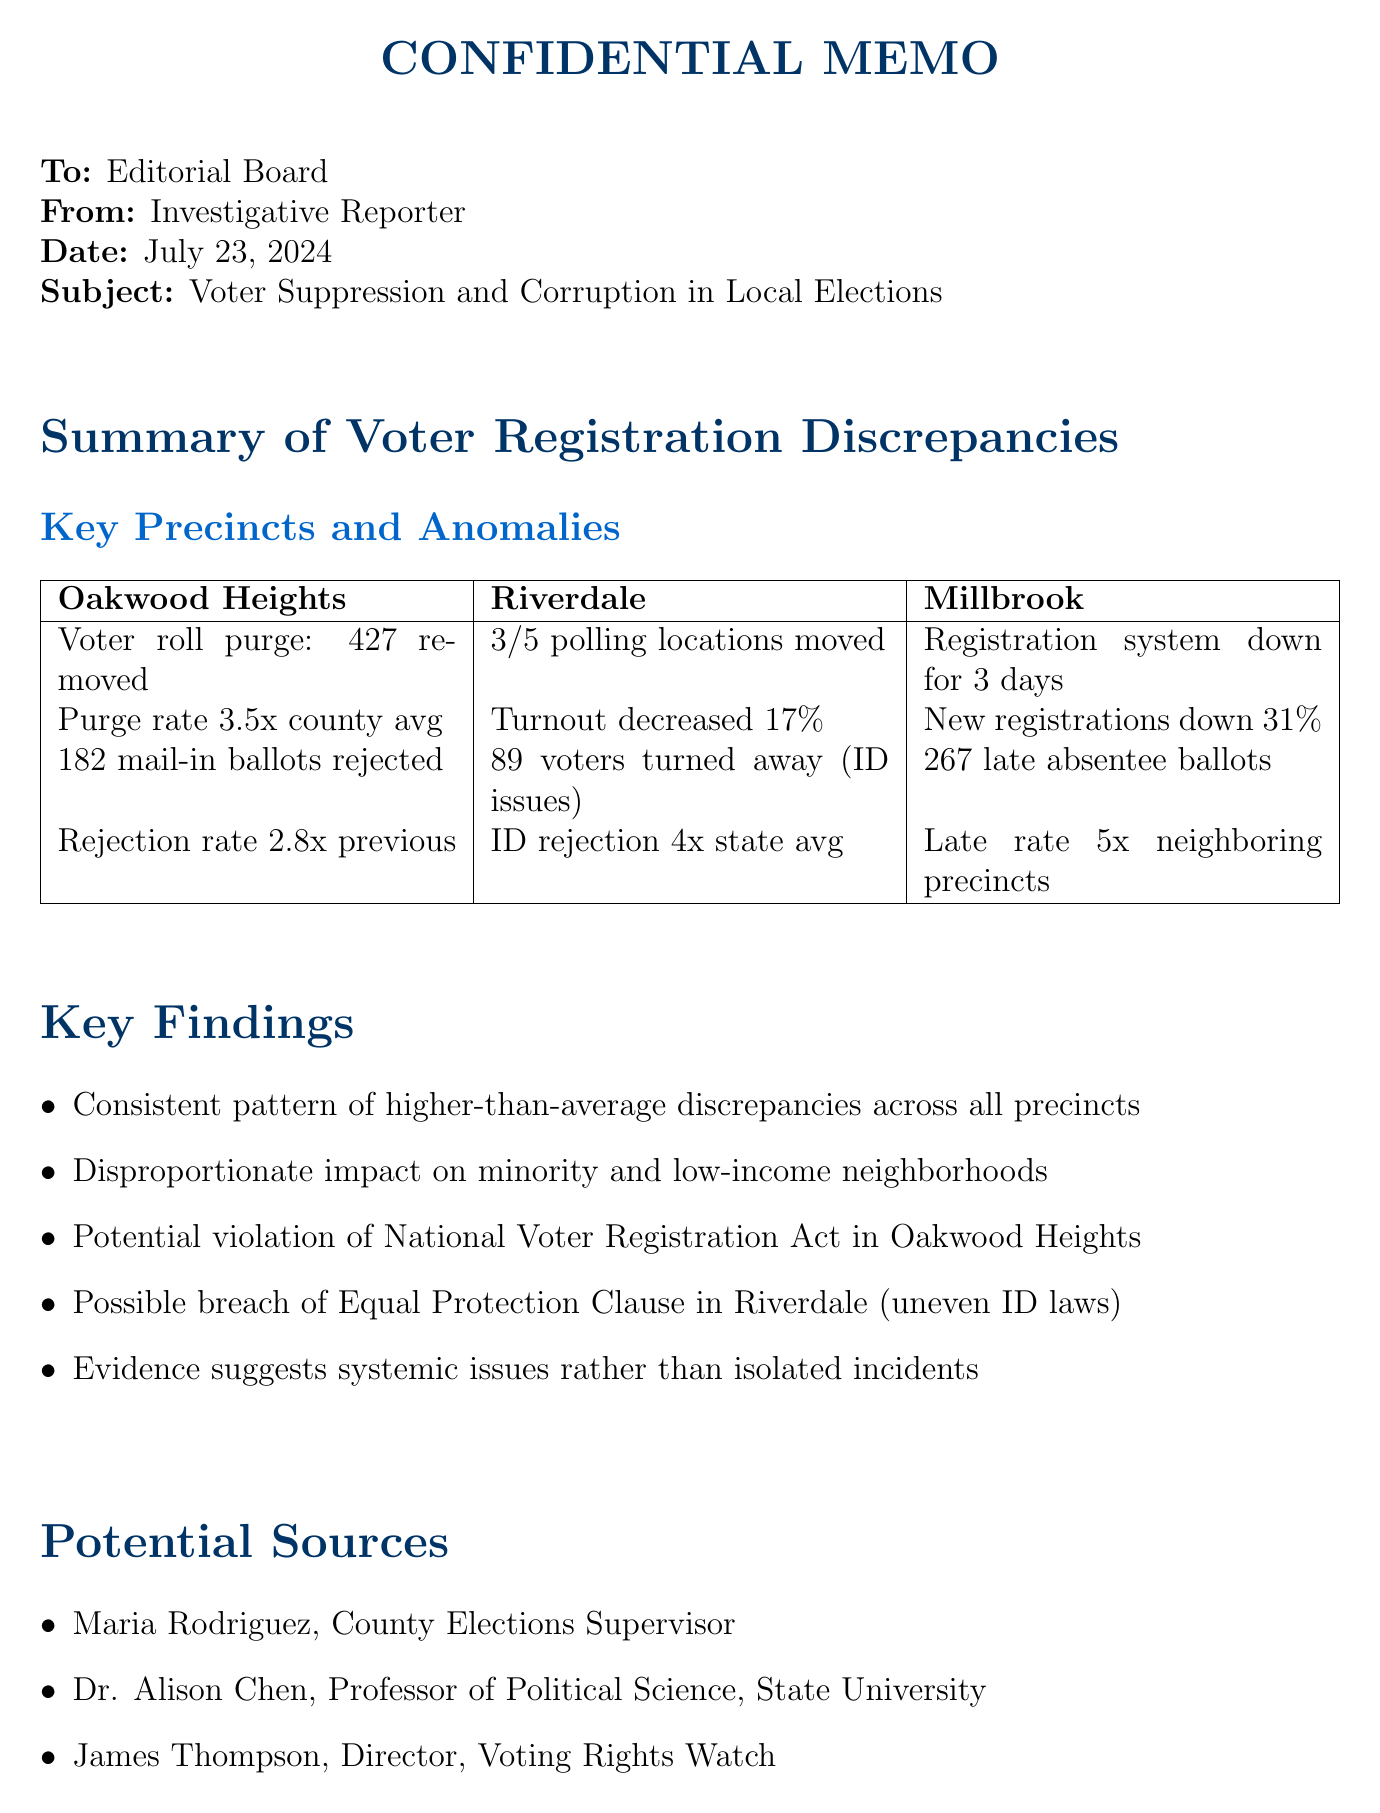What is the name of the precinct with the highest voter roll purge? The precinct with the highest voter roll purge is Oakwood Heights, which had 427 registered voters removed.
Answer: Oakwood Heights What is the statistical anomaly related to the absentee ballot delays in Millbrook? The absentee ballot delays in Millbrook had a late ballot rate 5 times higher than neighboring precincts.
Answer: 5 times higher How many polling locations in Riverdale were moved without adequate notice? In Riverdale, 3 out of 5 polling locations were moved without adequate notice.
Answer: 3 What was the voter turnout decrease in Riverdale compared to the last election? The voter turnout in Riverdale decreased by 17% compared to the last election.
Answer: 17% Which law is mentioned as potentially being violated in Oakwood Heights? The law that is potentially violated in Oakwood Heights is the National Voter Registration Act.
Answer: National Voter Registration Act Who is the County Elections Supervisor listed as a potential source? The County Elections Supervisor listed as a potential source is Maria Rodriguez.
Answer: Maria Rodriguez What issue caused the online registration system to be down in Millbrook? The issue that caused the online registration system to be down in Millbrook was a malfunction.
Answer: Malfunction What is the rejection rate for mail-in ballots due to signature mismatch in Oakwood Heights? The rejection rate for mail-in ballots due to signature mismatch in Oakwood Heights is 2.8 times higher than the previous election.
Answer: 2.8 times higher What is the total number of absentee ballots that arrived late in Millbrook? The total number of absentee ballots that arrived late in Millbrook was 267.
Answer: 267 